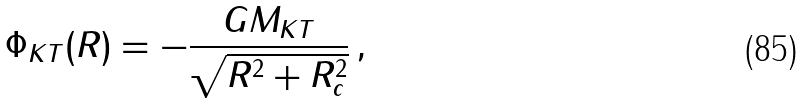<formula> <loc_0><loc_0><loc_500><loc_500>\Phi _ { K T } ( R ) = - \frac { G M _ { K T } } { \sqrt { R ^ { 2 } + R _ { c } ^ { 2 } } } \, ,</formula> 